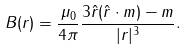<formula> <loc_0><loc_0><loc_500><loc_500>B ( r ) = { \frac { \mu _ { 0 } } { 4 \pi } } { \frac { 3 \hat { r } ( \hat { r } \cdot m ) - m } { | r | ^ { 3 } } } .</formula> 